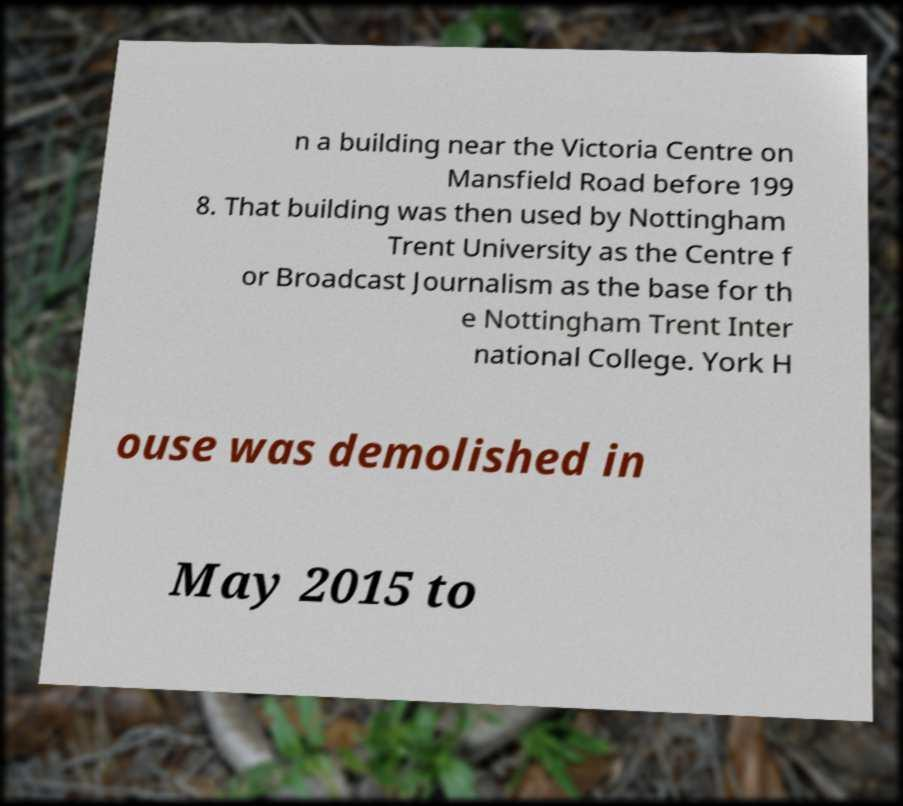Could you assist in decoding the text presented in this image and type it out clearly? n a building near the Victoria Centre on Mansfield Road before 199 8. That building was then used by Nottingham Trent University as the Centre f or Broadcast Journalism as the base for th e Nottingham Trent Inter national College. York H ouse was demolished in May 2015 to 